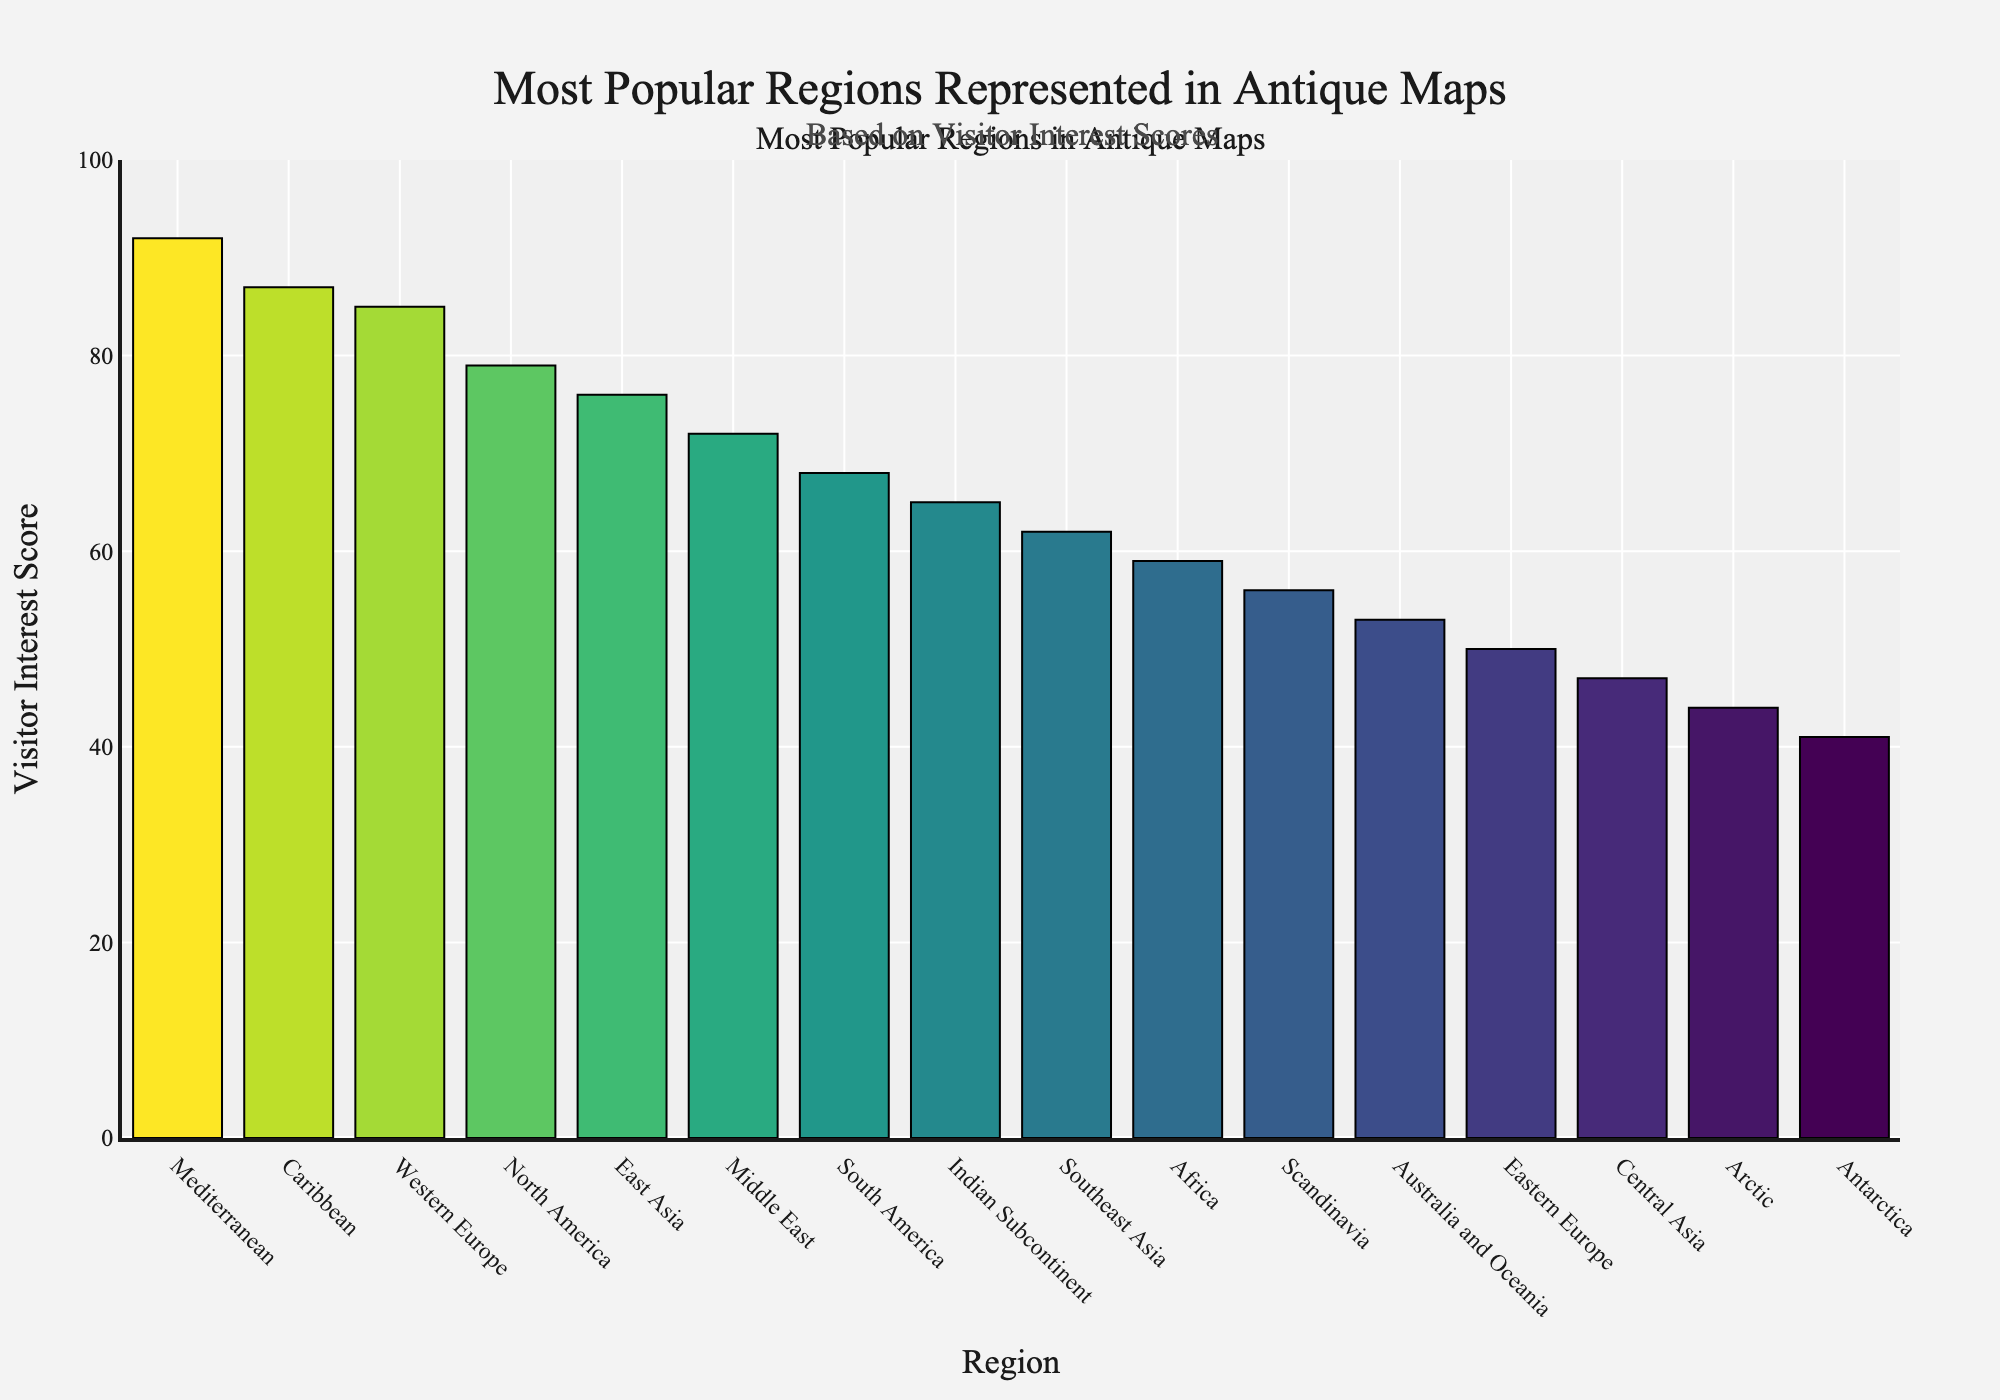What's the most popular region represented in antique maps based on visitor interest? The most popular region is represented by the tallest bar in the bar chart, which has the highest Visitor Interest Score.
Answer: Mediterranean Which region has a Visitor Interest Score of 76? By locating the bar with a height corresponding to the Visitor Interest Score of 76, we find the associated region.
Answer: East Asia What is the difference in Visitor Interest Scores between the Mediterranean and Antarctica? The Visitor Interest Score for the Mediterranean is 92 and for Antarctica is 41. The difference is calculated as 92 - 41.
Answer: 51 Which regions have Visitor Interest Scores greater than 80? By examining the bars that exceed the 80 mark on the y-axis, we identify the corresponding regions.
Answer: Mediterranean, Caribbean, Western Europe How many regions have a Visitor Interest Score below 60? Counting the bars with heights corresponding to scores below 60 gives us the number of such regions.
Answer: 7 What is the average Visitor Interest Score of the top three regions? The Visitor Interest Scores for the top three regions are 92, 87, and 85. The average is calculated as (92 + 87 + 85) / 3.
Answer: 88 Which region is just below the Caribbean in terms of Visitor Interest Score? The region with a slightly lower bar than the Caribbean’s bar (87) is the next one.
Answer: Western Europe What is the median Visitor Interest Score of all the regions? Arranging the Visitor Interest Scores in ascending order and finding the middle value. The scores are: 41, 44, 47, 50, 53, 56, 59, 62, 65, 68, 72, 76, 79, 85, 87, 92. The median is the average of the 8th and 9th values (62 and 65).
Answer: 63.5 Are there more regions with a Visitor Interest Score above 70 or below 50? Counting the regions with scores above 70 (Mediterranean, Caribbean, Western Europe, North America, East Asia, Middle East) and those below 50 (Central Asia, Arctic, Antarctica), and comparing the two counts.
Answer: Above 70 Which region has a darker color compared to the Indian Subcontinent on the bar chart, and what does this signify? Finding the bars with a deeper color than the Indian Subcontinent bar indicates that they have higher Visitor Interest Scores.
Answer: Caribbean, Western Europe, North America, East Asia, Middle East 